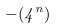Convert formula to latex. <formula><loc_0><loc_0><loc_500><loc_500>- ( 4 ^ { n } )</formula> 